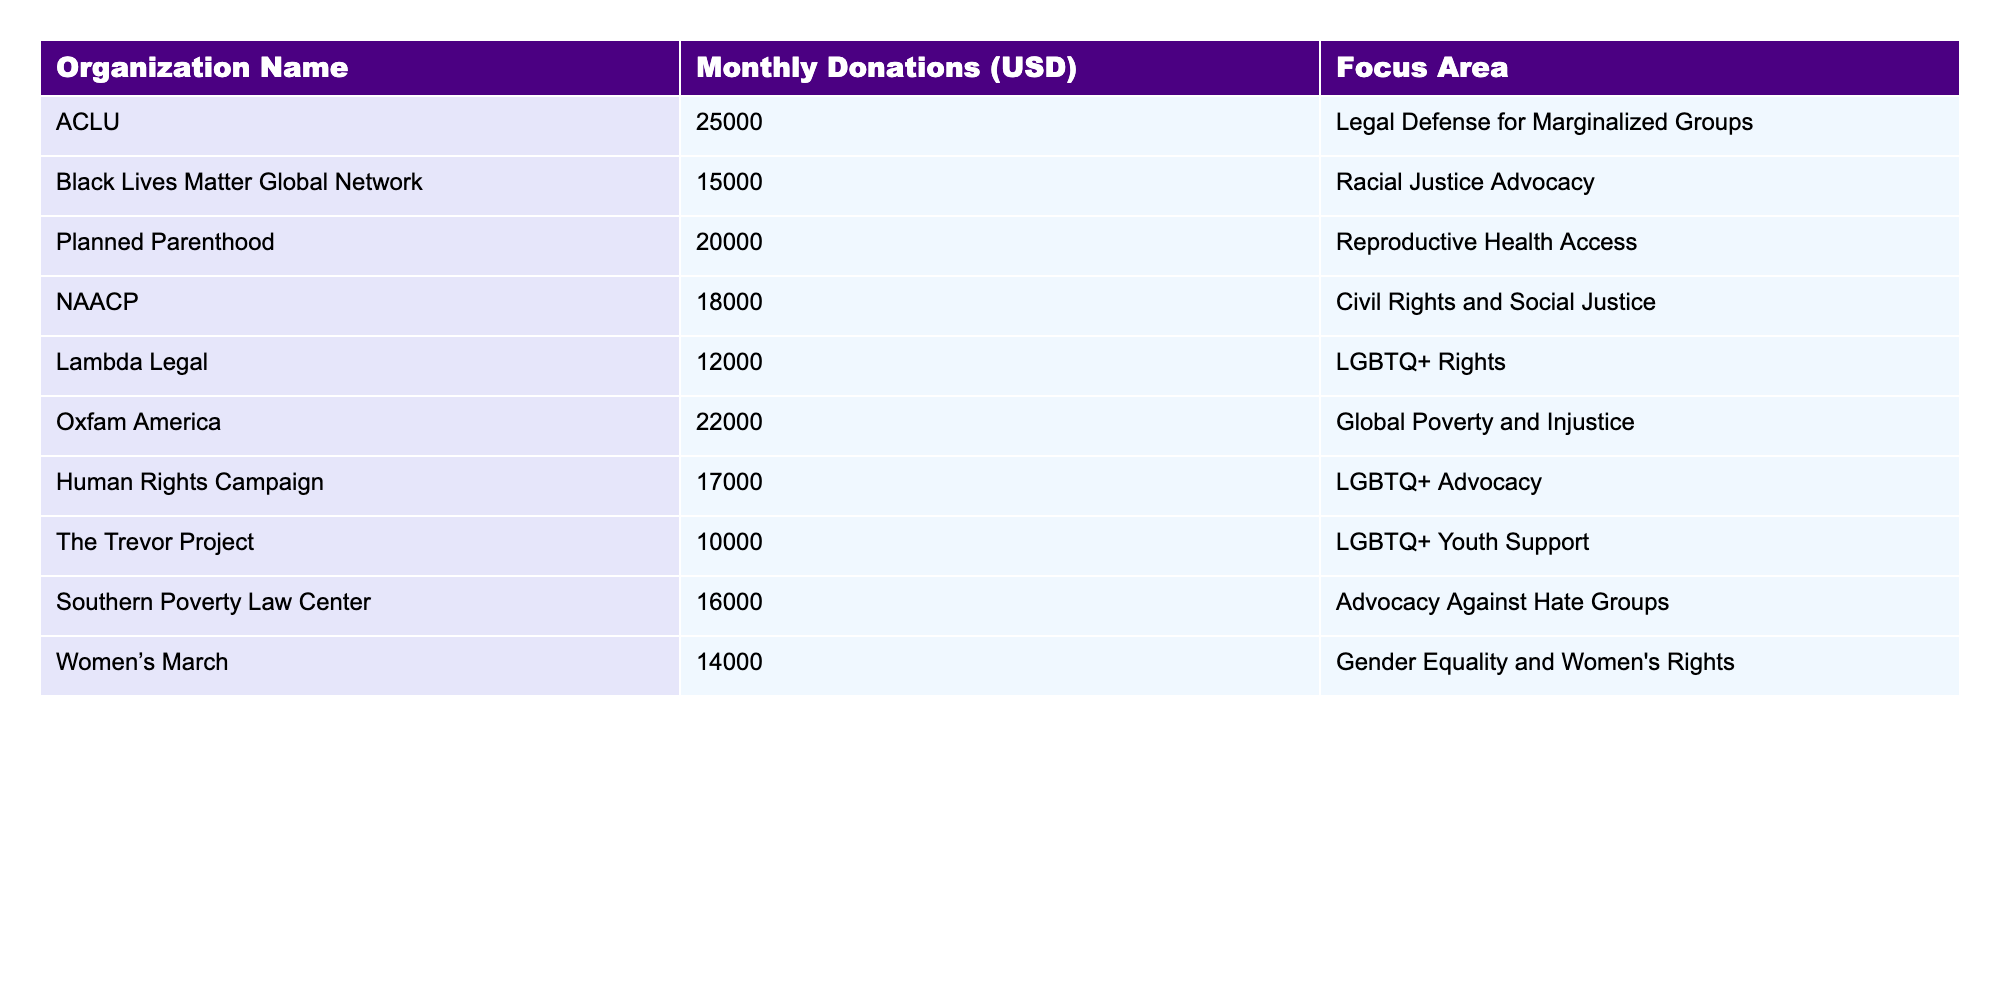What is the organization with the highest monthly donations? By looking at the table, the organization with the highest monthly donations is ACLU, which has a total of 25,000 USD.
Answer: ACLU Which organization received monthly donations of 12,000 USD? The table indicates that Lambda Legal is the organization that received monthly donations of 12,000 USD.
Answer: Lambda Legal What is the total amount of monthly donations received by all organizations listed? To find the total, add all the monthly donations: 25,000 + 15,000 + 20,000 + 18,000 + 12,000 + 22,000 + 17,000 + 10,000 + 16,000 + 14,000 =  179,000 USD.
Answer: 179,000 USD What is the average monthly donation amount from the organizations listed? The average is calculated by dividing the total donations (179,000 USD) by the number of organizations (10): 179,000 / 10 = 17,900 USD.
Answer: 17,900 USD Which focus area has the second highest total monthly donations? First, sum the donations for each focus area: Legal Defense (25,000), Racial Justice (15,000), Reproductive Health (20,000), Civil Rights (18,000), LGBTQ+ Rights (12,000 + 17,000 + 10,000), Global Poverty (22,000), Gender Equality (14,000). The second highest is Racial Justice (15,000), totaling 22,000 for LGBTQ+.
Answer: LGBTQ+ Rights Does Planned Parenthood receive more monthly donations than the NAACP? Planned Parenthood receives 20,000 USD while NAACP receives 18,000 USD. Since 20,000 is greater than 18,000, the statement is true.
Answer: Yes What is the difference in monthly donations between the organization with the highest and the lowest donations? The highest is ACLU with 25,000 USD and the lowest is The Trevor Project with 10,000 USD. The difference is 25,000 - 10,000 = 15,000 USD.
Answer: 15,000 USD Which two organizations focused on LGBTQ+ rights have a total monthly donation higher than 30,000 USD? Lambda Legal (12,000) and Human Rights Campaign (17,000) combine to 29,000, while The Trevor Project (10,000) adds up to 39,000 for a total of 39,000 - 12,000 = 27,000 USD for Lambda Legal and HRC combined.
Answer: None 